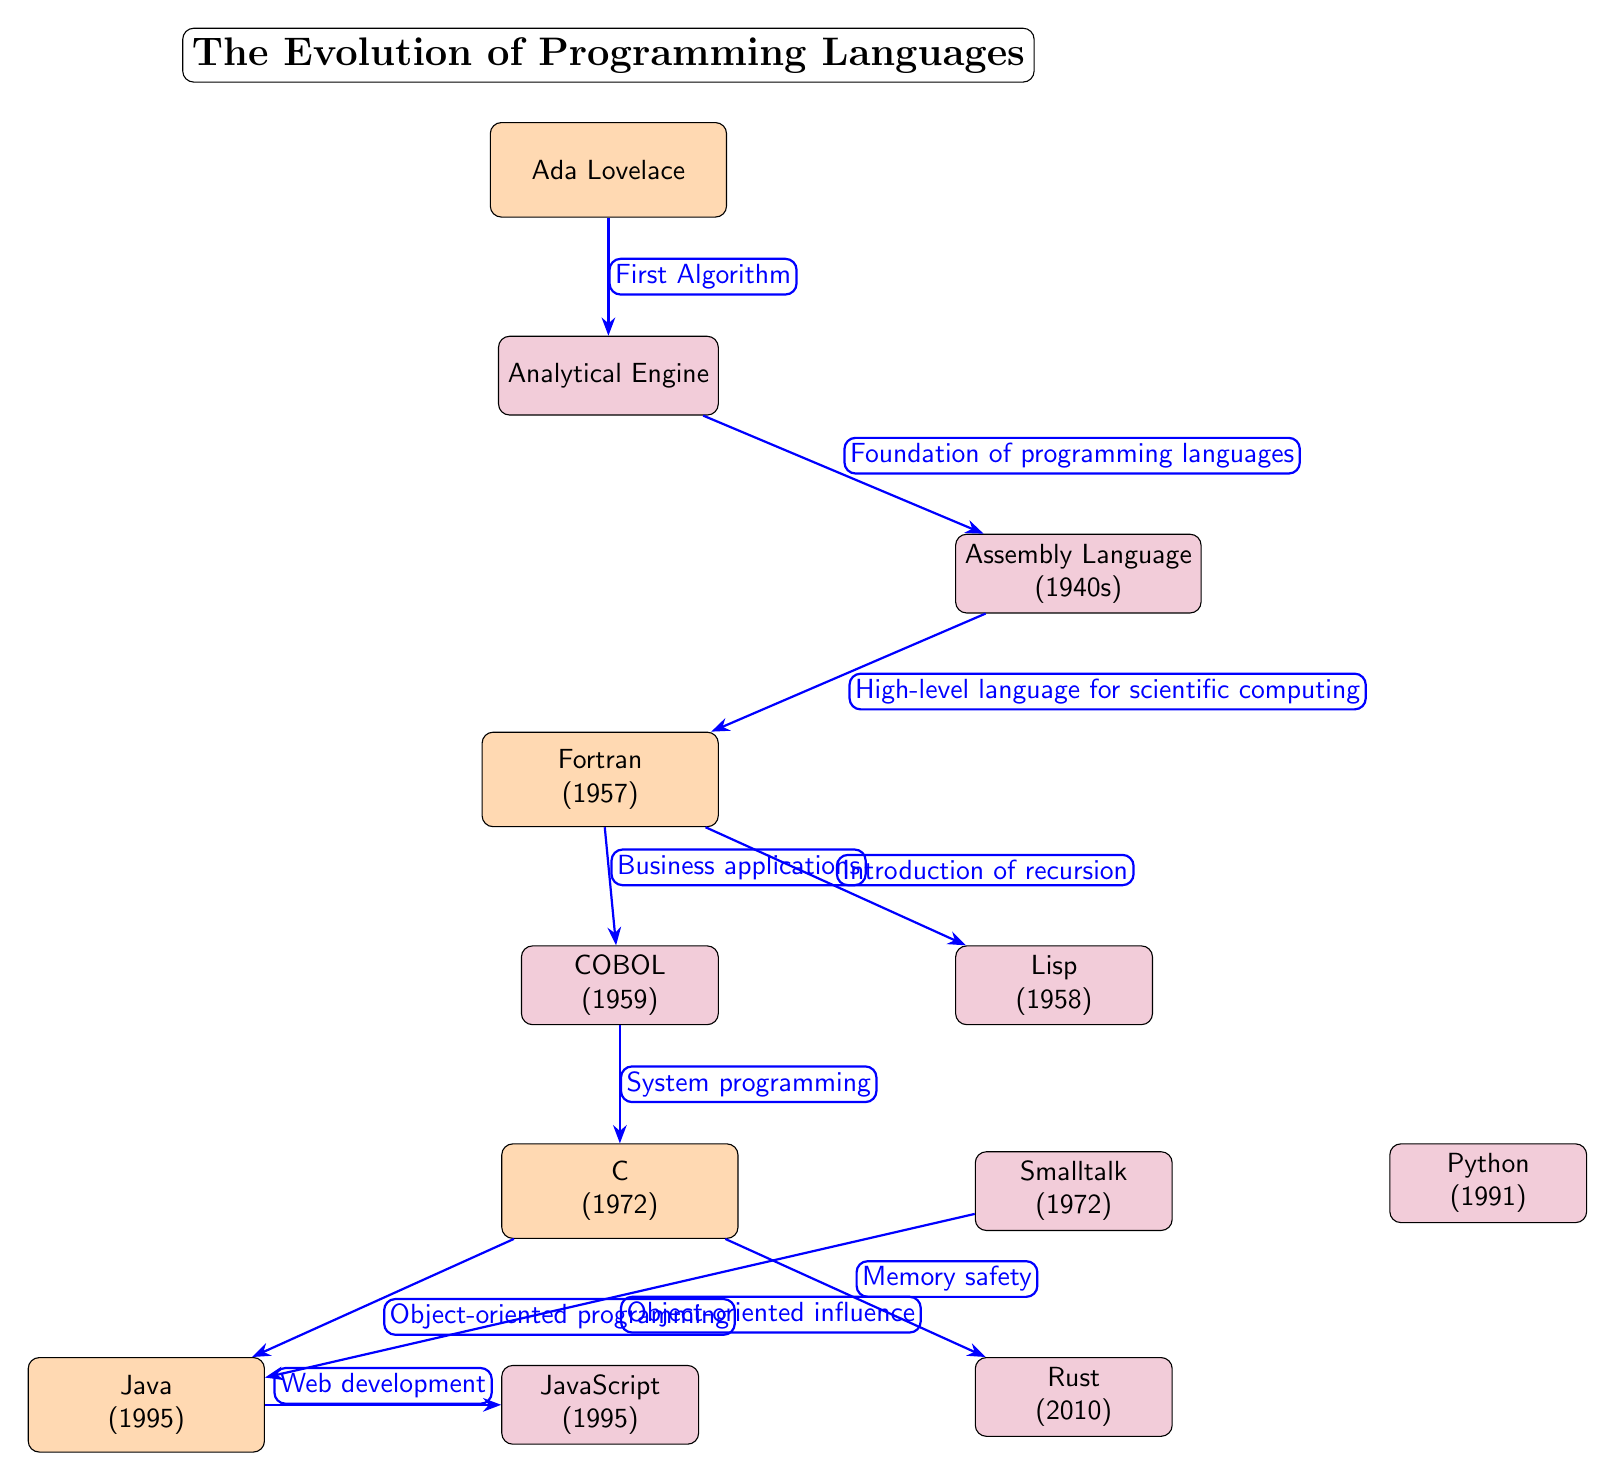What is the first algorithm in the diagram? The first node in the diagram represents Ada Lovelace, who is known for creating the first algorithm for Charles Babbage's Analytical Engine. This is indicated by the label connecting Ada Lovelace to the Analytical Engine.
Answer: Ada Lovelace Which programming language was introduced in 1957? The diagram displays several programming languages along with their introduction years. The node that lists Fortran has the year 1957 specified next to it.
Answer: Fortran How many milestones are identified in the diagram? By counting the nodes that are classified as milestones, which are represented as distinct entities with a different color (orange), we find that Ada Lovelace, Fortran, C, Java, and Smalltalk fit this category. Thus, the total is five.
Answer: Five What relationship is indicated between Fortran and Lisp? The diagram shows an arrow connecting Fortran to Lisp, with the label "Introduction of recursion". This indicates that among its contributions, Fortran led to the introduction of the concept of recursion in the programming language Lisp.
Answer: Introduction of recursion Which programming language is associated with web development according to the diagram? The diagram shows an arrow leading from the Java node to the JavaScript node, with the label "Web development". This clearly identifies JavaScript as the programming language associated with web development.
Answer: JavaScript What major change in programming does C provide compared to COBOL? COBOL is connected to C with an arrow labeled "System programming", whereas C points to Java with the label "Object-oriented programming". This indicates that C introduces the paradigm of object-oriented programming, which is a significant evolution from COBOL's focus.
Answer: Object-oriented programming What is the last programming language depicted in the diagram? By observing the flow and layout of the nodes in the diagram, the last language to appear is Rust, which is placed below C and contains the year 2010 next to it.
Answer: Rust Which language is directly influenced by Smalltalk? Tracing the arrows in the diagram, Smalltalk points to Java with the label "Object-oriented influence". This indicates that Java was influenced by Smalltalk in its design and programming paradigms.
Answer: Java What does the arrow between Analytical Engine and Assembly Language signify? The arrow from the Analytical Engine to Assembly Language carries the label "Foundation of programming languages", suggesting that the Analytical Engine laid the groundwork for the development of Assembly Language as one of the earliest programming constructs.
Answer: Foundation of programming languages 